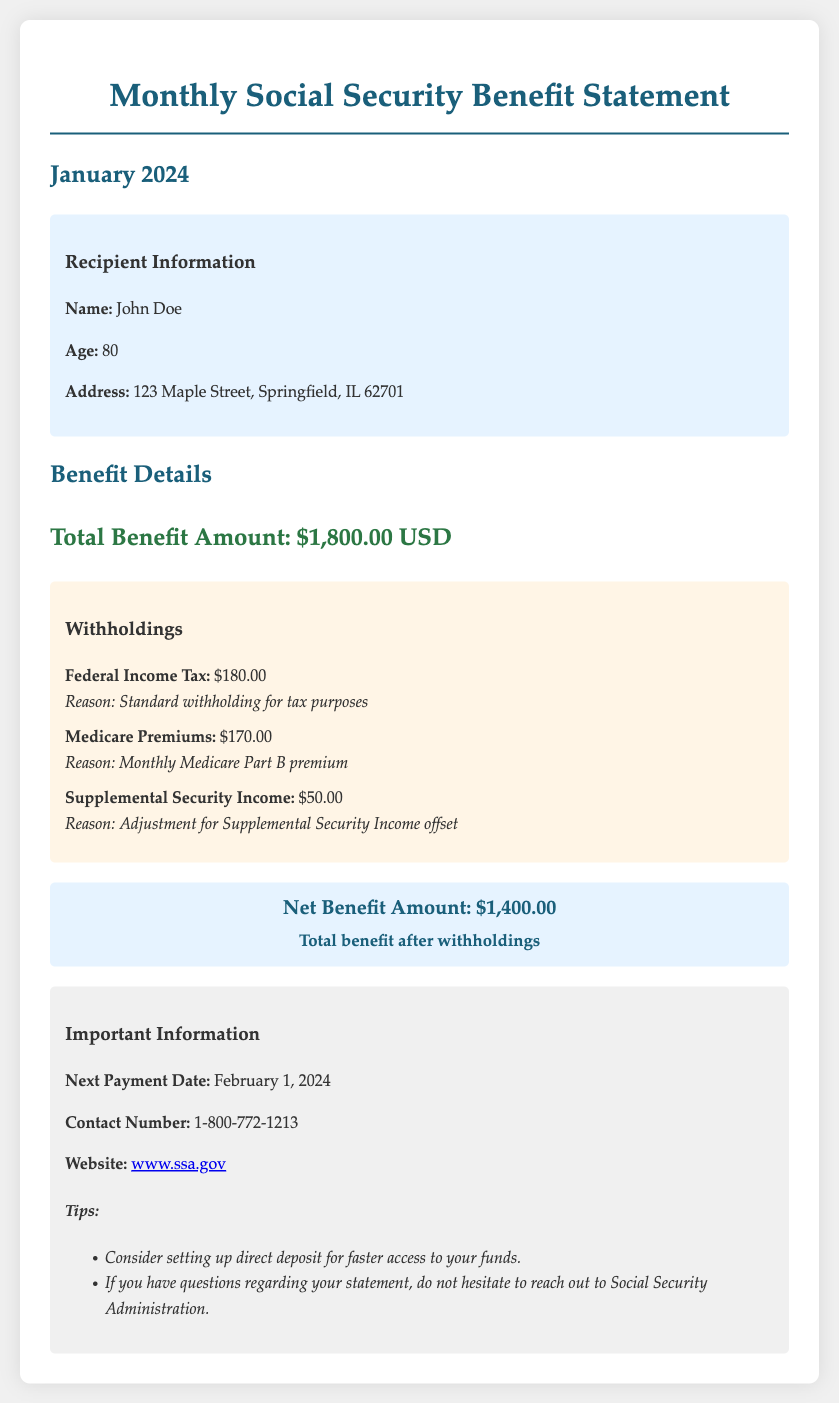What is the total benefit amount? The total benefit amount is specified in the benefit details section of the document as $1,800.00 USD.
Answer: $1,800.00 USD What is the net benefit amount after withholdings? The net benefit is calculated as the total benefit amount minus the total withholdings, which is stated as $1,400.00 in the document.
Answer: $1,400.00 How much is withheld for Federal Income Tax? The withholding amount for Federal Income Tax is indicated in the withholdings section as $180.00.
Answer: $180.00 What is the reason for the Medicare Premium withholding? The reason for the Medicare Premium withholding is described in the document as the monthly Medicare Part B premium.
Answer: Monthly Medicare Part B premium What is the recipient's age? The recipient's age is provided in the recipient information section, which states that the recipient is 80 years old.
Answer: 80 What is the next payment date? The next payment date is mentioned in the important information section as February 1, 2024.
Answer: February 1, 2024 How much is deducted for Supplemental Security Income? The deduction for Supplemental Security Income is listed in the withholdings section as $50.00.
Answer: $50.00 What is the address of the recipient? The recipient's address is detailed in the recipient information section, which states 123 Maple Street, Springfield, IL 62701.
Answer: 123 Maple Street, Springfield, IL 62701 What is the contact number for inquiries? The contact number for inquiries is provided in the important information section as 1-800-772-1213.
Answer: 1-800-772-1213 